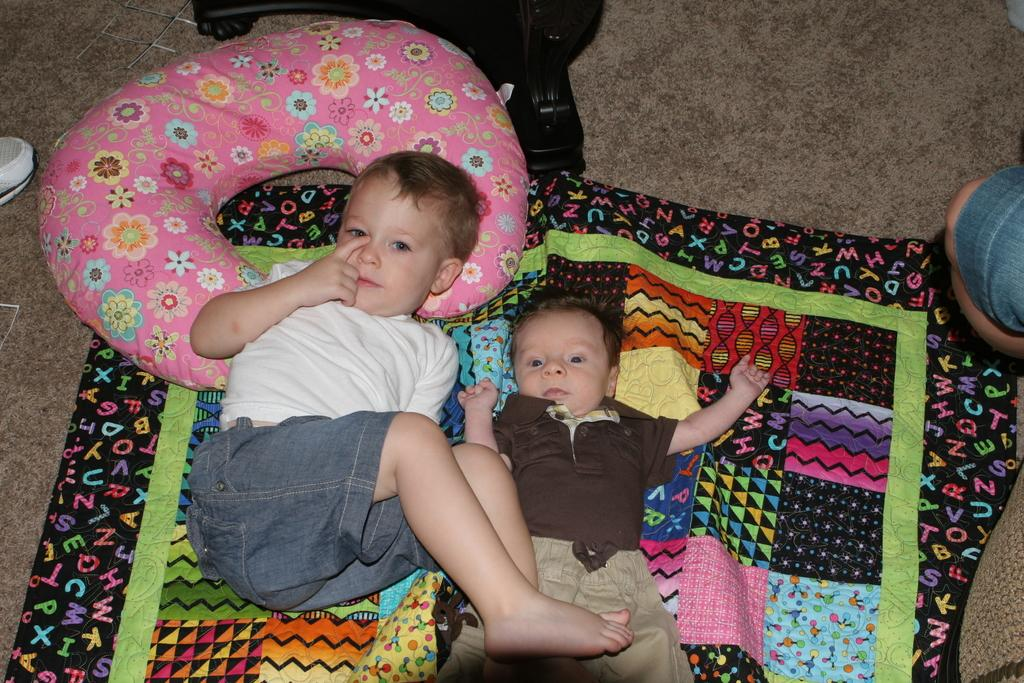How many children are in the image? There are two children in the image. What are the children doing in the image? The children are lying on a cloth. Can you describe any objects that might be used for comfort in the image? There is an object that looks like a pillow in the image. What is on the floor in the image? There is an object on the floor in the image. Whose leg is visible in the image? A person's leg is visible in the image. Can you tell me how many toads are hopping around in the image? There are no toads present in the image. What type of game are the children playing in the image? The image does not show the children playing any game. 